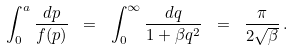<formula> <loc_0><loc_0><loc_500><loc_500>\int _ { 0 } ^ { a } \frac { d p } { f ( p ) } \ = \ \int _ { 0 } ^ { \infty } \frac { d q } { 1 + \beta q ^ { 2 } } \ = \ \frac { \pi } { 2 \sqrt { \beta } } \, .</formula> 